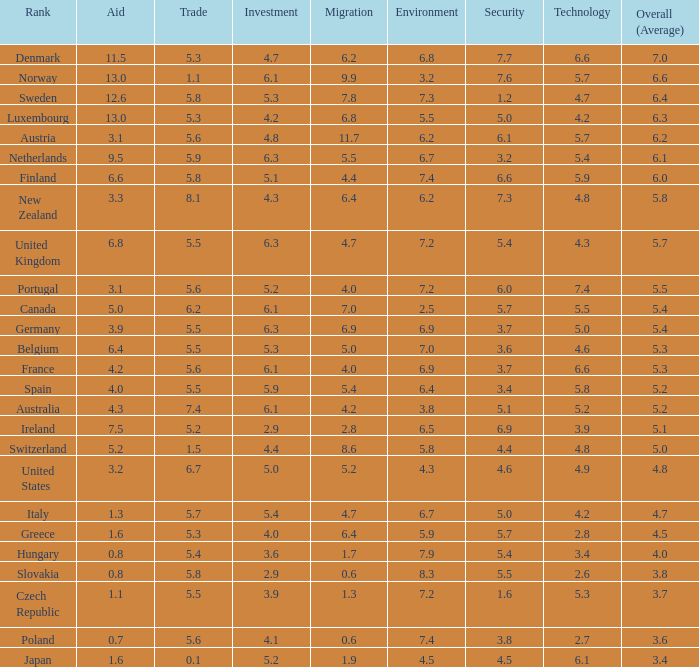5 rating for security? Slovakia. 